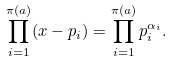<formula> <loc_0><loc_0><loc_500><loc_500>\prod _ { i = 1 } ^ { \pi ( a ) } ( x - p _ { i } ) = \prod _ { i = 1 } ^ { \pi ( a ) } p _ { i } ^ { \alpha _ { i } } .</formula> 